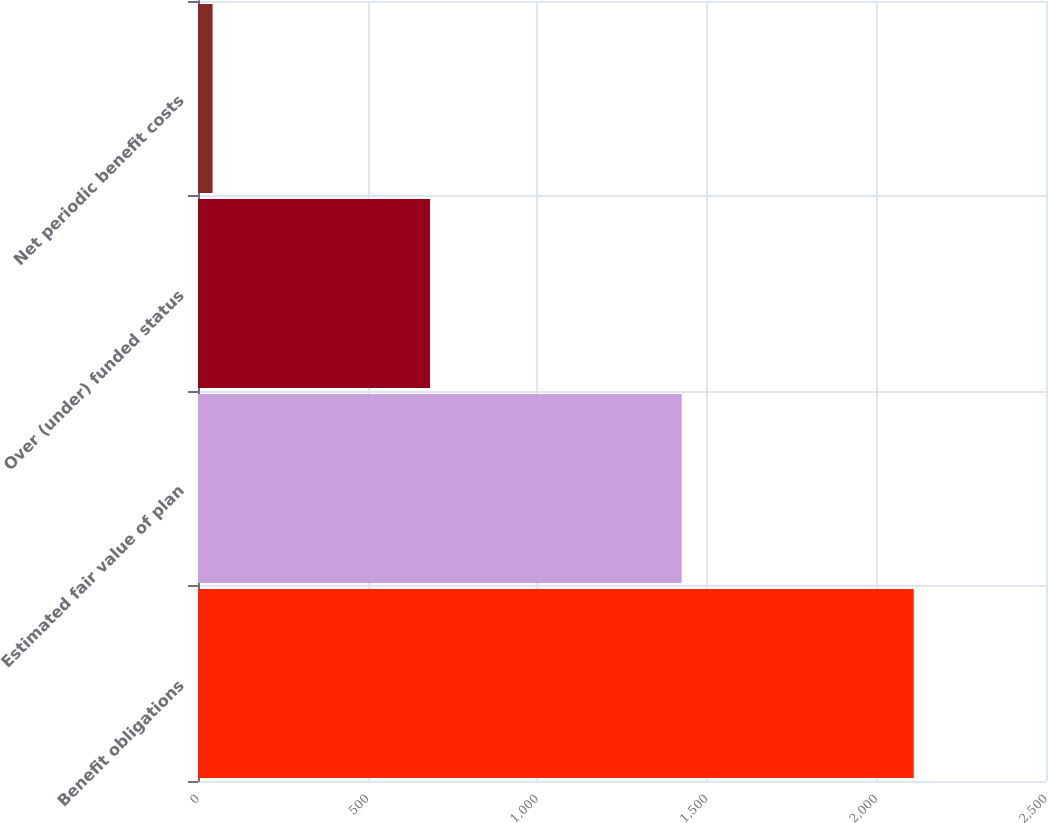<chart> <loc_0><loc_0><loc_500><loc_500><bar_chart><fcel>Benefit obligations<fcel>Estimated fair value of plan<fcel>Over (under) funded status<fcel>Net periodic benefit costs<nl><fcel>2110<fcel>1426<fcel>684<fcel>43<nl></chart> 